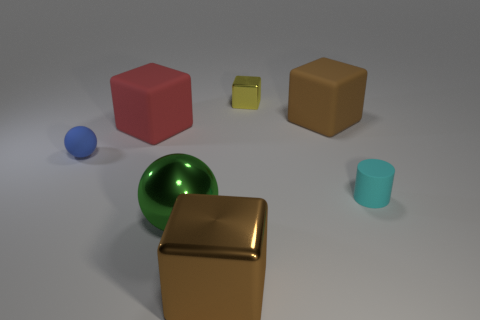How many objects are small yellow shiny objects or large brown objects that are in front of the cyan cylinder?
Your response must be concise. 2. What material is the other object that is the same shape as the tiny blue thing?
Offer a terse response. Metal. There is a big brown thing that is left of the small yellow object; is its shape the same as the big red matte thing?
Your answer should be compact. Yes. Are there fewer brown shiny things that are to the left of the green metallic sphere than small cyan matte cylinders on the right side of the brown rubber object?
Provide a succinct answer. Yes. What number of other objects are the same shape as the green thing?
Offer a terse response. 1. How big is the metal cube to the right of the brown cube to the left of the big brown block that is behind the tiny cyan matte thing?
Make the answer very short. Small. How many yellow objects are either matte blocks or metallic objects?
Offer a terse response. 1. The matte thing in front of the sphere behind the tiny cyan matte thing is what shape?
Offer a very short reply. Cylinder. Is the size of the brown block that is right of the brown metal block the same as the shiny cube behind the large brown metal thing?
Your response must be concise. No. Is there a purple cylinder that has the same material as the small cyan cylinder?
Provide a short and direct response. No. 